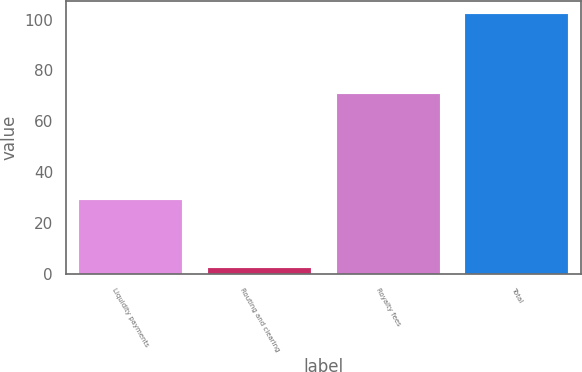Convert chart to OTSL. <chart><loc_0><loc_0><loc_500><loc_500><bar_chart><fcel>Liquidity payments<fcel>Routing and clearing<fcel>Royalty fees<fcel>Total<nl><fcel>29.2<fcel>2.3<fcel>70.6<fcel>102.1<nl></chart> 